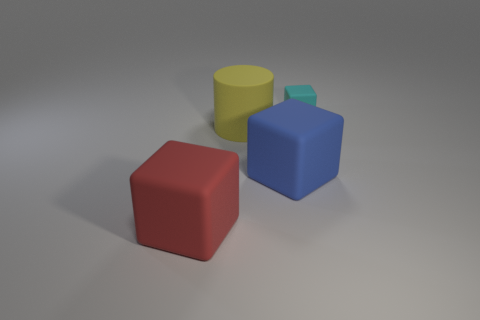What is the color of the big matte block left of the large rubber cube that is behind the large rubber object to the left of the large matte cylinder?
Provide a short and direct response. Red. What number of matte objects are in front of the large cylinder and right of the big yellow cylinder?
Make the answer very short. 1. There is a matte thing to the left of the yellow thing; is it the same color as the cube that is behind the yellow cylinder?
Your response must be concise. No. Is there anything else that has the same material as the big blue block?
Provide a short and direct response. Yes. The cyan thing that is the same shape as the red rubber object is what size?
Your answer should be very brief. Small. There is a red rubber cube; are there any small cyan matte blocks behind it?
Give a very brief answer. Yes. Are there the same number of matte objects that are behind the yellow object and tiny gray matte cylinders?
Offer a very short reply. No. Are there any large red objects that are behind the cube on the right side of the big rubber block right of the large red matte cube?
Offer a terse response. No. What is the cylinder made of?
Give a very brief answer. Rubber. What number of other things are there of the same shape as the large yellow thing?
Your answer should be very brief. 0. 